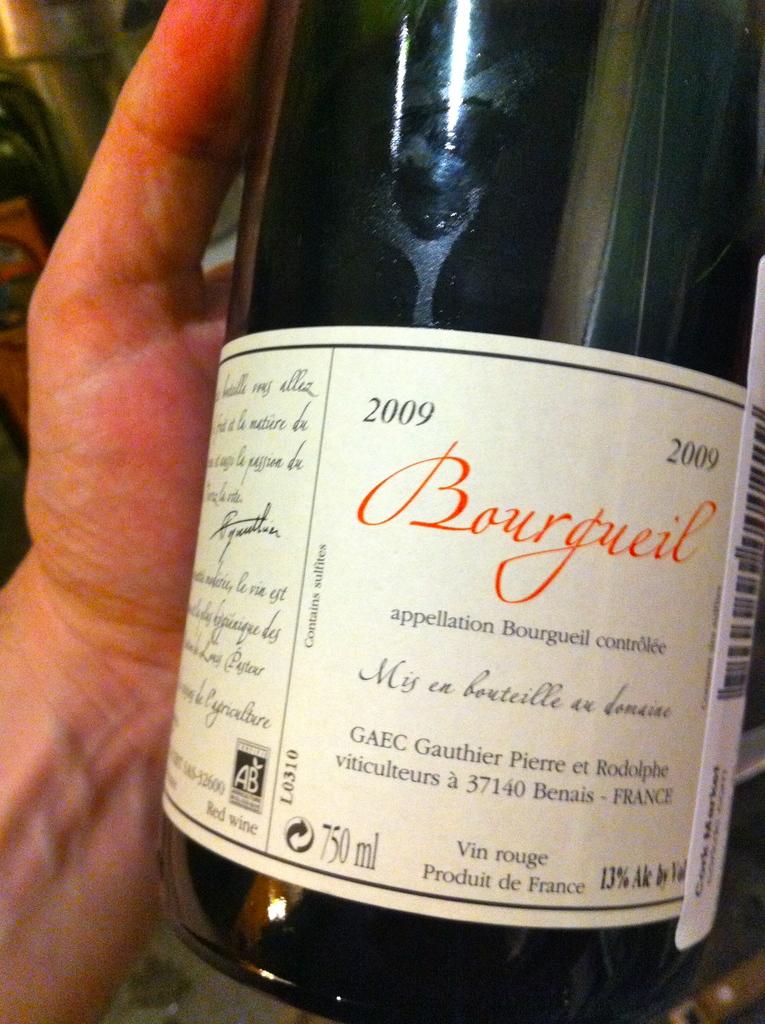What year was the wine made?
Offer a very short reply. 2009. 